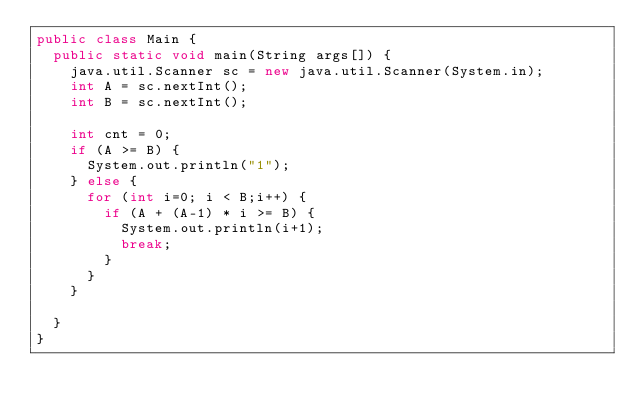<code> <loc_0><loc_0><loc_500><loc_500><_Java_>public class Main {
	public static void main(String args[]) {
		java.util.Scanner sc = new java.util.Scanner(System.in);
		int A = sc.nextInt();
		int B = sc.nextInt();

		int cnt = 0;
		if (A >= B) {
			System.out.println("1");
		} else {
			for (int i=0; i < B;i++) {
				if (A + (A-1) * i >= B) {
					System.out.println(i+1);
					break;
				}
			}
		}

	}
}</code> 